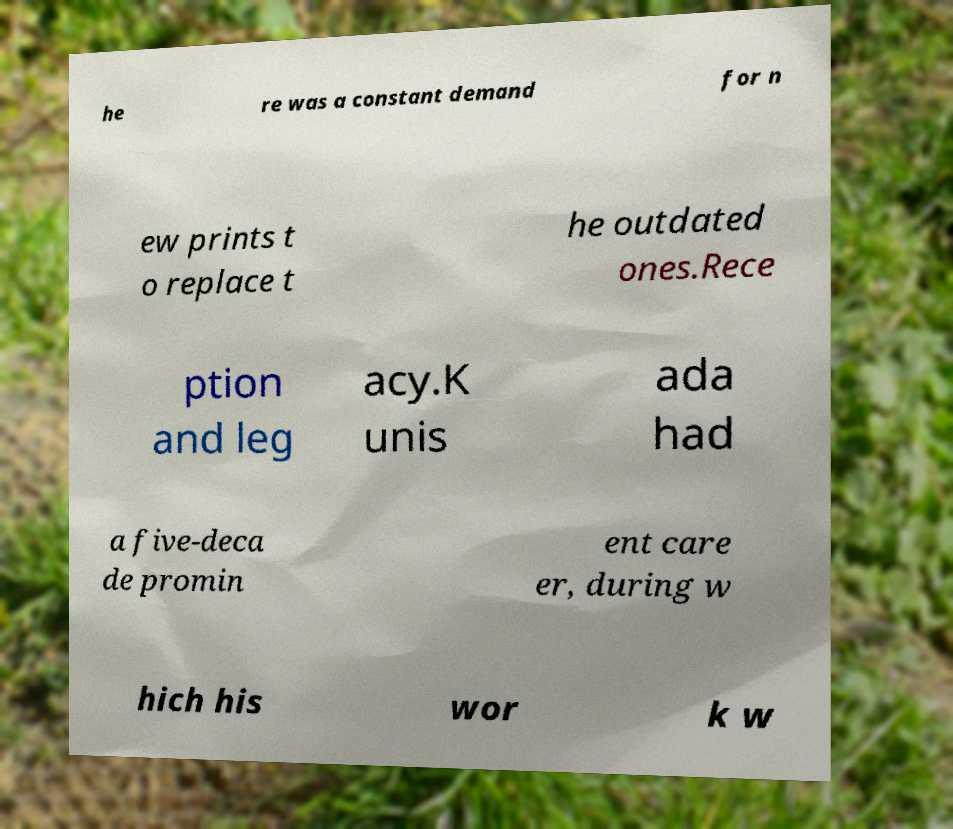Can you read and provide the text displayed in the image?This photo seems to have some interesting text. Can you extract and type it out for me? he re was a constant demand for n ew prints t o replace t he outdated ones.Rece ption and leg acy.K unis ada had a five-deca de promin ent care er, during w hich his wor k w 